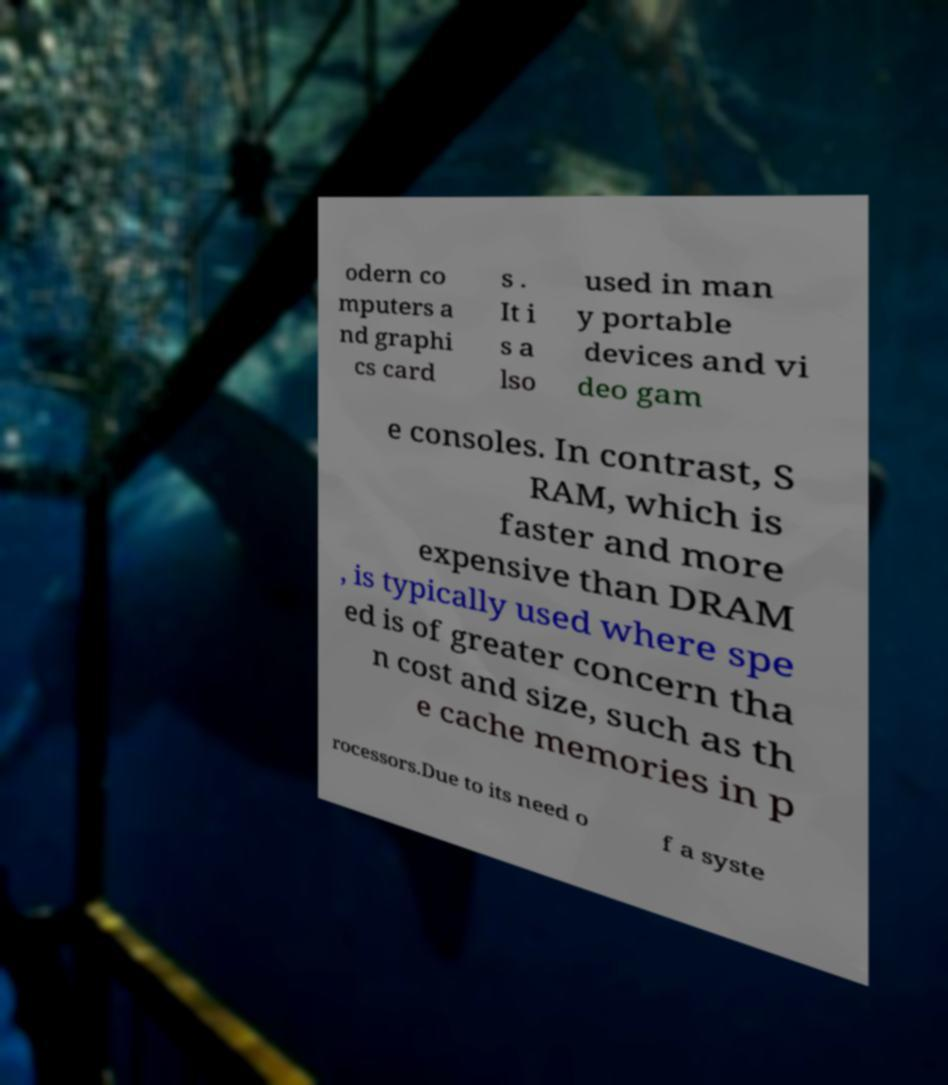Can you accurately transcribe the text from the provided image for me? odern co mputers a nd graphi cs card s . It i s a lso used in man y portable devices and vi deo gam e consoles. In contrast, S RAM, which is faster and more expensive than DRAM , is typically used where spe ed is of greater concern tha n cost and size, such as th e cache memories in p rocessors.Due to its need o f a syste 